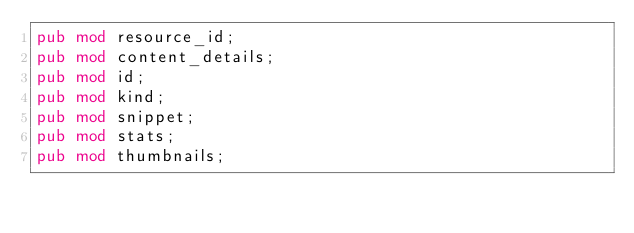<code> <loc_0><loc_0><loc_500><loc_500><_Rust_>pub mod resource_id;
pub mod content_details;
pub mod id;
pub mod kind;
pub mod snippet;
pub mod stats;
pub mod thumbnails;
</code> 